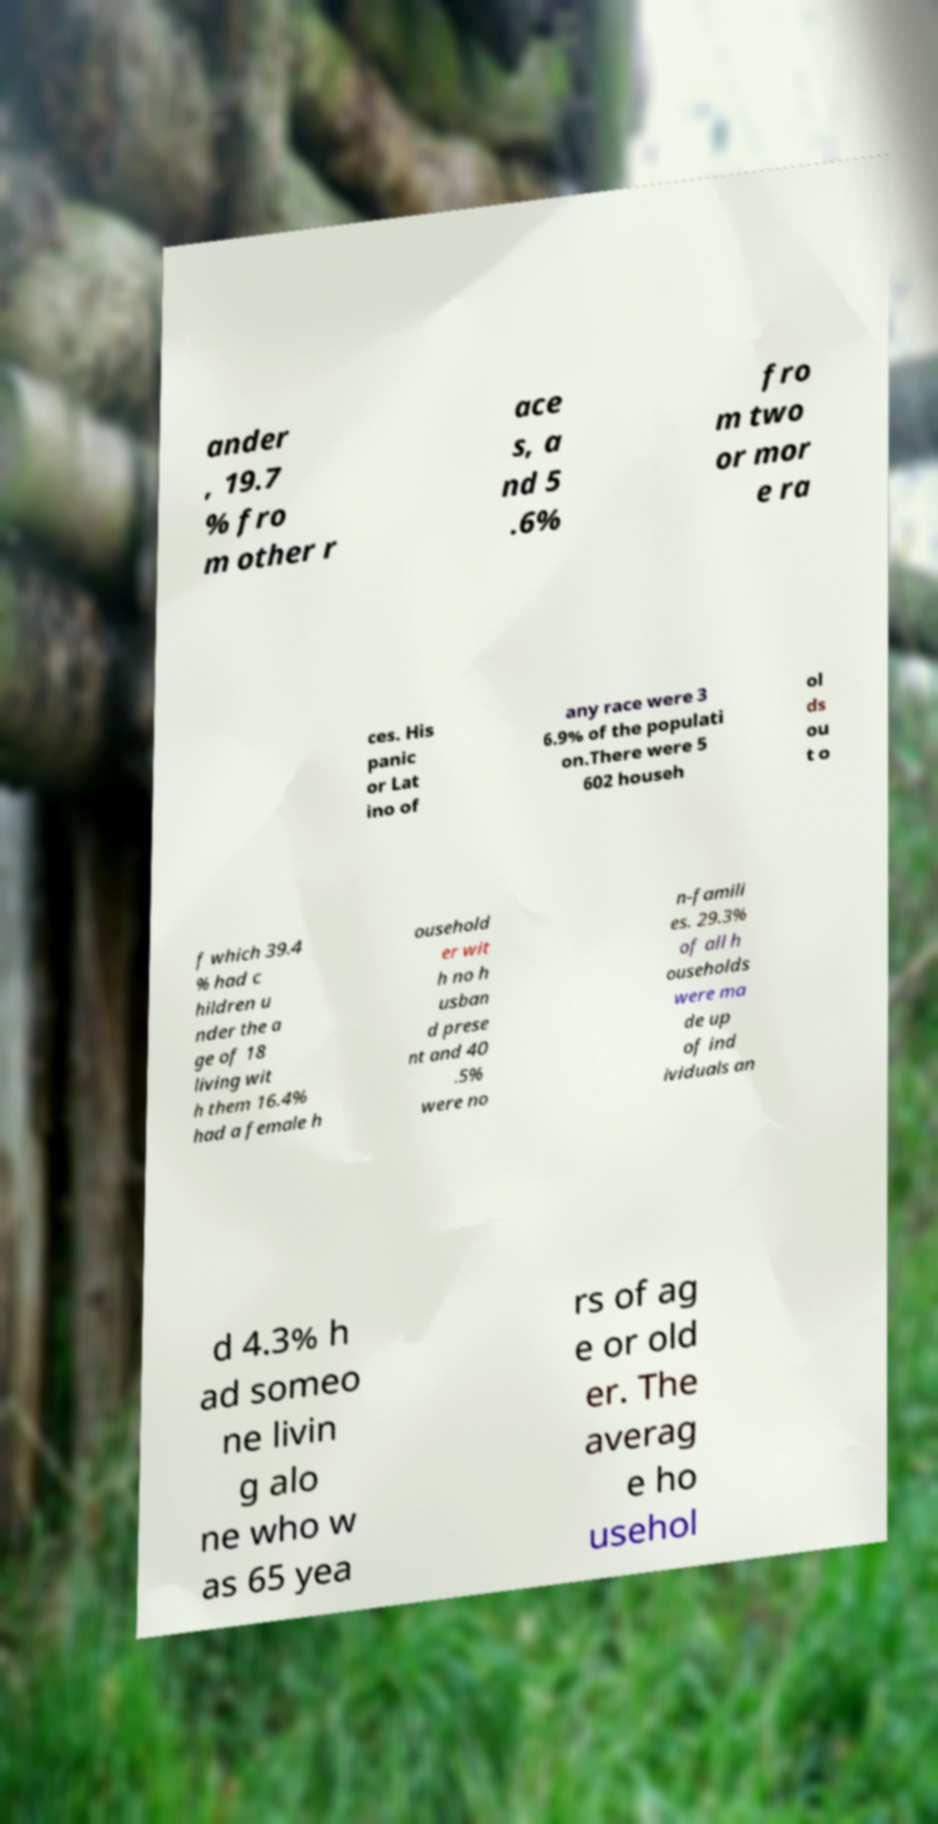Could you extract and type out the text from this image? ander , 19.7 % fro m other r ace s, a nd 5 .6% fro m two or mor e ra ces. His panic or Lat ino of any race were 3 6.9% of the populati on.There were 5 602 househ ol ds ou t o f which 39.4 % had c hildren u nder the a ge of 18 living wit h them 16.4% had a female h ousehold er wit h no h usban d prese nt and 40 .5% were no n-famili es. 29.3% of all h ouseholds were ma de up of ind ividuals an d 4.3% h ad someo ne livin g alo ne who w as 65 yea rs of ag e or old er. The averag e ho usehol 